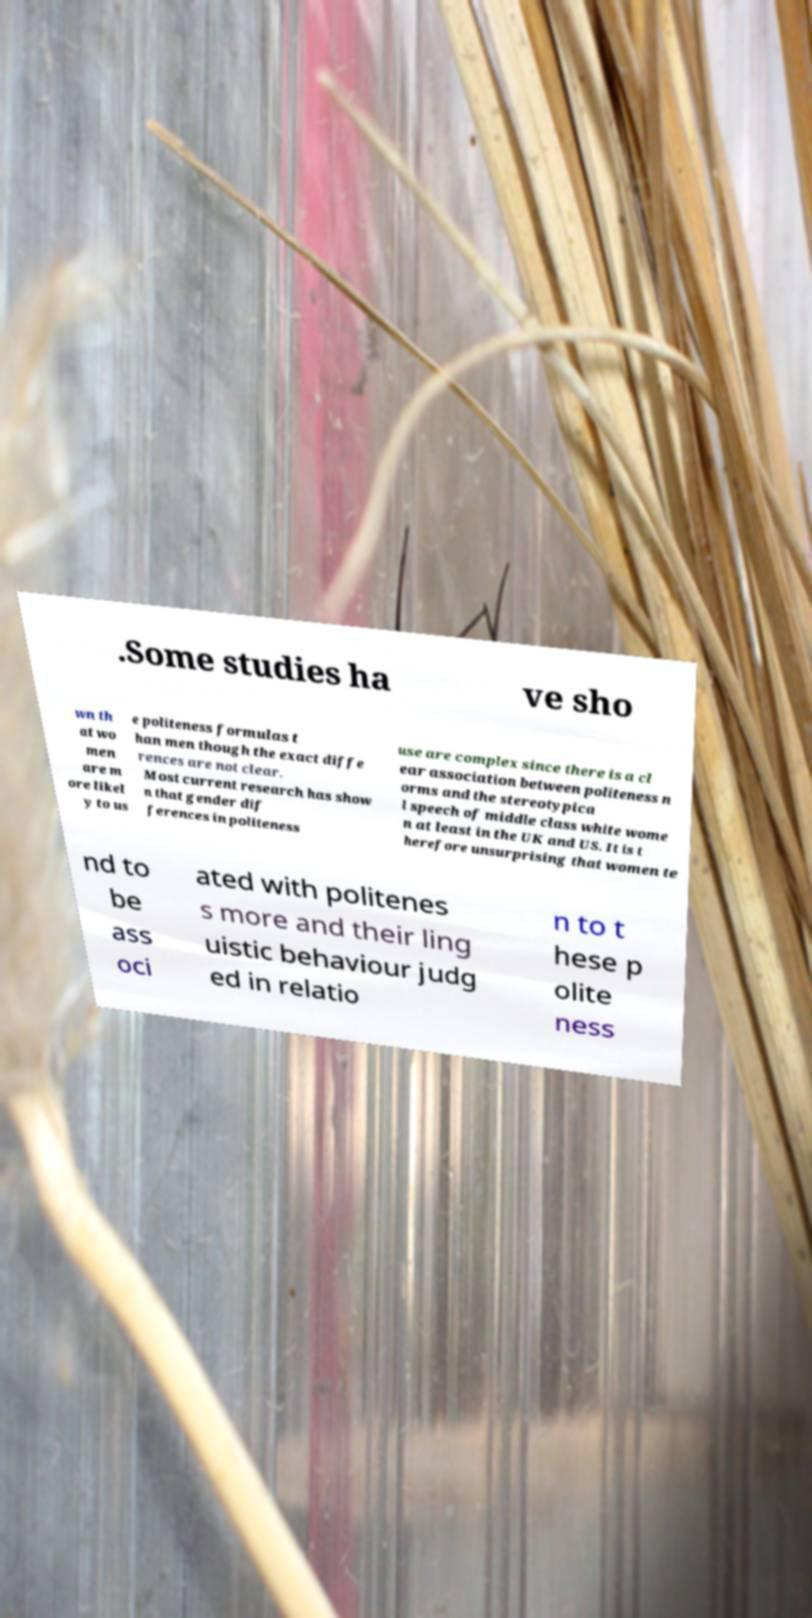What messages or text are displayed in this image? I need them in a readable, typed format. .Some studies ha ve sho wn th at wo men are m ore likel y to us e politeness formulas t han men though the exact diffe rences are not clear. Most current research has show n that gender dif ferences in politeness use are complex since there is a cl ear association between politeness n orms and the stereotypica l speech of middle class white wome n at least in the UK and US. It is t herefore unsurprising that women te nd to be ass oci ated with politenes s more and their ling uistic behaviour judg ed in relatio n to t hese p olite ness 